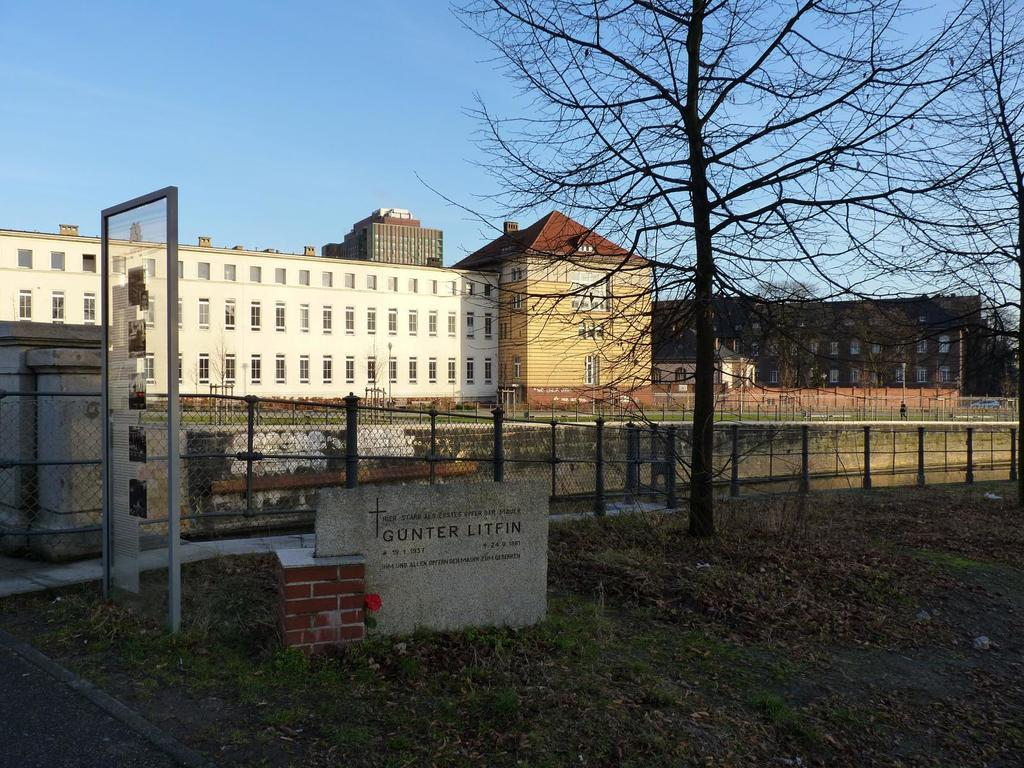What type of structures are present in the image? There are buildings with windows in the image. What features do the buildings have? The buildings have roofs. What natural element can be seen in the image? There is a tree in the image. What man-made element can be seen in the image? There is a fence in the image. What type of plant is visible in the image? There is a flower in the image. What object can be seen in the image that is not a building, tree, fence, or flower? There is a board in the image. What is the condition of the sky in the image? The sky is visible in the image and appears cloudy. How many kites are being flown by the lizards in the image? There are no kites or lizards present in the image. What are the boys doing in the image? There are no boys present in the image. 